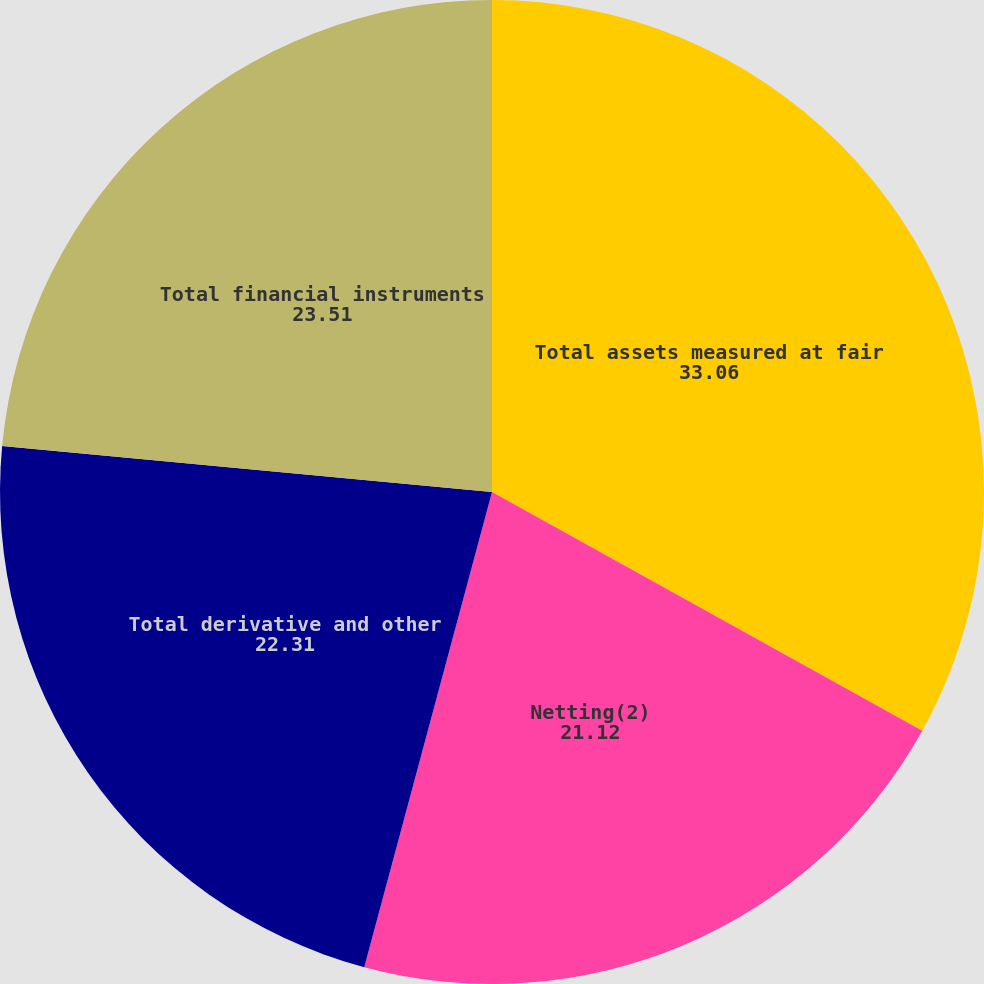Convert chart. <chart><loc_0><loc_0><loc_500><loc_500><pie_chart><fcel>Total assets measured at fair<fcel>Netting(2)<fcel>Total derivative and other<fcel>Total financial instruments<nl><fcel>33.06%<fcel>21.12%<fcel>22.31%<fcel>23.51%<nl></chart> 